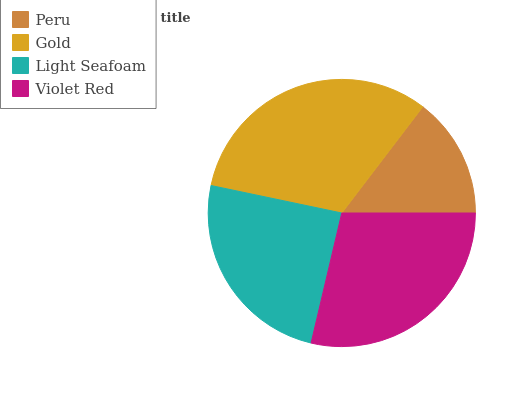Is Peru the minimum?
Answer yes or no. Yes. Is Gold the maximum?
Answer yes or no. Yes. Is Light Seafoam the minimum?
Answer yes or no. No. Is Light Seafoam the maximum?
Answer yes or no. No. Is Gold greater than Light Seafoam?
Answer yes or no. Yes. Is Light Seafoam less than Gold?
Answer yes or no. Yes. Is Light Seafoam greater than Gold?
Answer yes or no. No. Is Gold less than Light Seafoam?
Answer yes or no. No. Is Violet Red the high median?
Answer yes or no. Yes. Is Light Seafoam the low median?
Answer yes or no. Yes. Is Gold the high median?
Answer yes or no. No. Is Peru the low median?
Answer yes or no. No. 